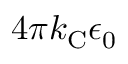Convert formula to latex. <formula><loc_0><loc_0><loc_500><loc_500>4 \pi k _ { C } \epsilon _ { 0 }</formula> 